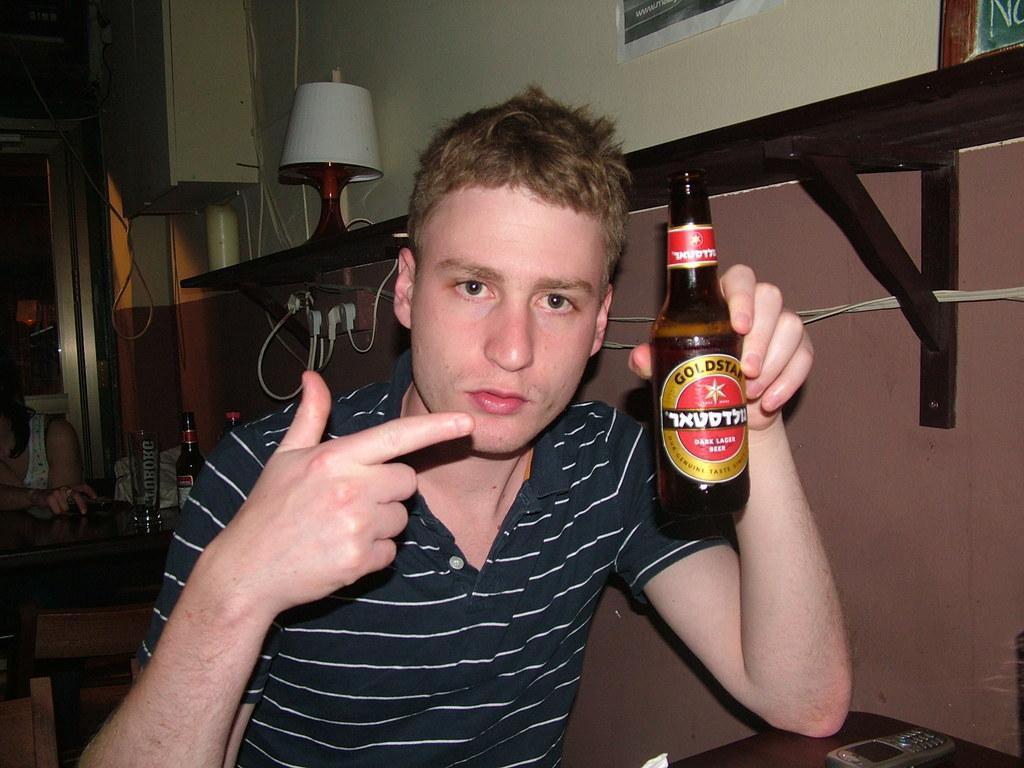Describe this image in one or two sentences. In this picture there is a boy who is sitting at the center of the image, by holding a bottle in his hand, there is a lamp at the left side of the image and there is a desk and a door at the left side of the image, and there is a cell phone on the table at the right side of the image, it seems to be a hotel. 